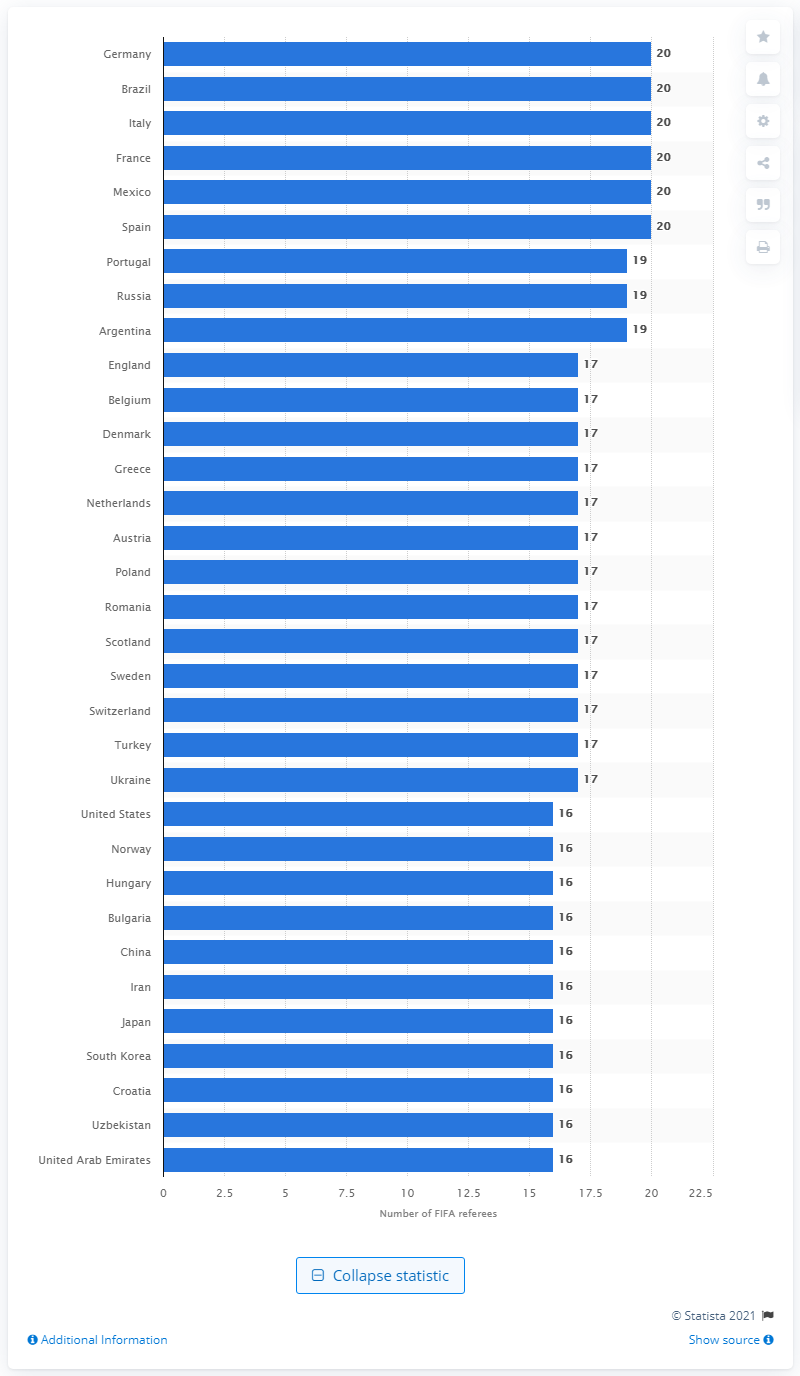Specify some key components in this picture. In February 2014, 20 of the referees came from France. 